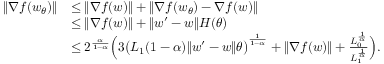<formula> <loc_0><loc_0><loc_500><loc_500>\begin{array} { r l } { \| \nabla f ( w _ { \theta } ) \| } & { \leq \| \nabla f ( w ) \| + \| \nabla f ( w _ { \theta } ) - \nabla f ( w ) \| } \\ & { \leq \| \nabla f ( w ) \| + \| w ^ { \prime } - w \| H ( \theta ) } \\ & { \leq 2 ^ { \frac { \alpha } { 1 - \alpha } } \left ( 3 \left ( L _ { 1 } ( 1 - \alpha ) \| w ^ { \prime } - w \| \theta \right ) ^ { \frac { 1 } { 1 - \alpha } } + \| \nabla f ( w ) \| + \frac { L _ { 0 } ^ { \frac { 1 } { \alpha } } } { L _ { 1 } ^ { \frac { 1 } { \alpha } } } \right ) . } \end{array}</formula> 